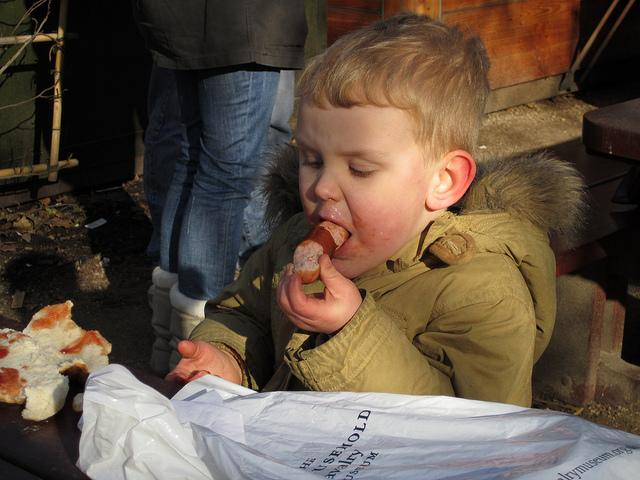Why is the food eaten by the boy unhealthy? carbs 